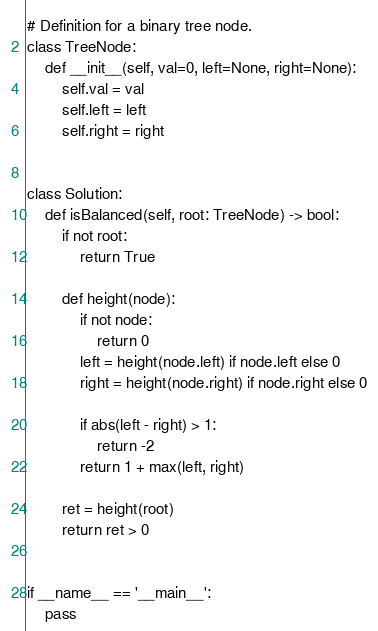Convert code to text. <code><loc_0><loc_0><loc_500><loc_500><_Python_># Definition for a binary tree node.
class TreeNode:
    def __init__(self, val=0, left=None, right=None):
        self.val = val
        self.left = left
        self.right = right


class Solution:
    def isBalanced(self, root: TreeNode) -> bool:
        if not root:
            return True

        def height(node):
            if not node:
                return 0
            left = height(node.left) if node.left else 0
            right = height(node.right) if node.right else 0

            if abs(left - right) > 1:
                return -2
            return 1 + max(left, right)

        ret = height(root)
        return ret > 0


if __name__ == '__main__':
    pass
</code> 